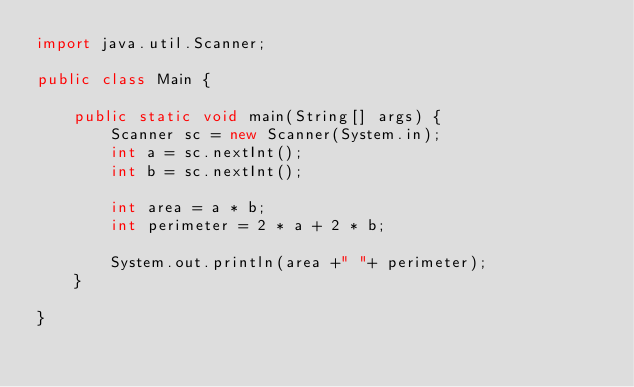Convert code to text. <code><loc_0><loc_0><loc_500><loc_500><_Java_>import java.util.Scanner;

public class Main {

	public static void main(String[] args) {
    	Scanner sc = new Scanner(System.in);
    	int a = sc.nextInt();
    	int b = sc.nextInt();

    	int area = a * b;
    	int perimeter = 2 * a + 2 * b;
    	
    	System.out.println(area +" "+ perimeter);
	}

}
</code> 